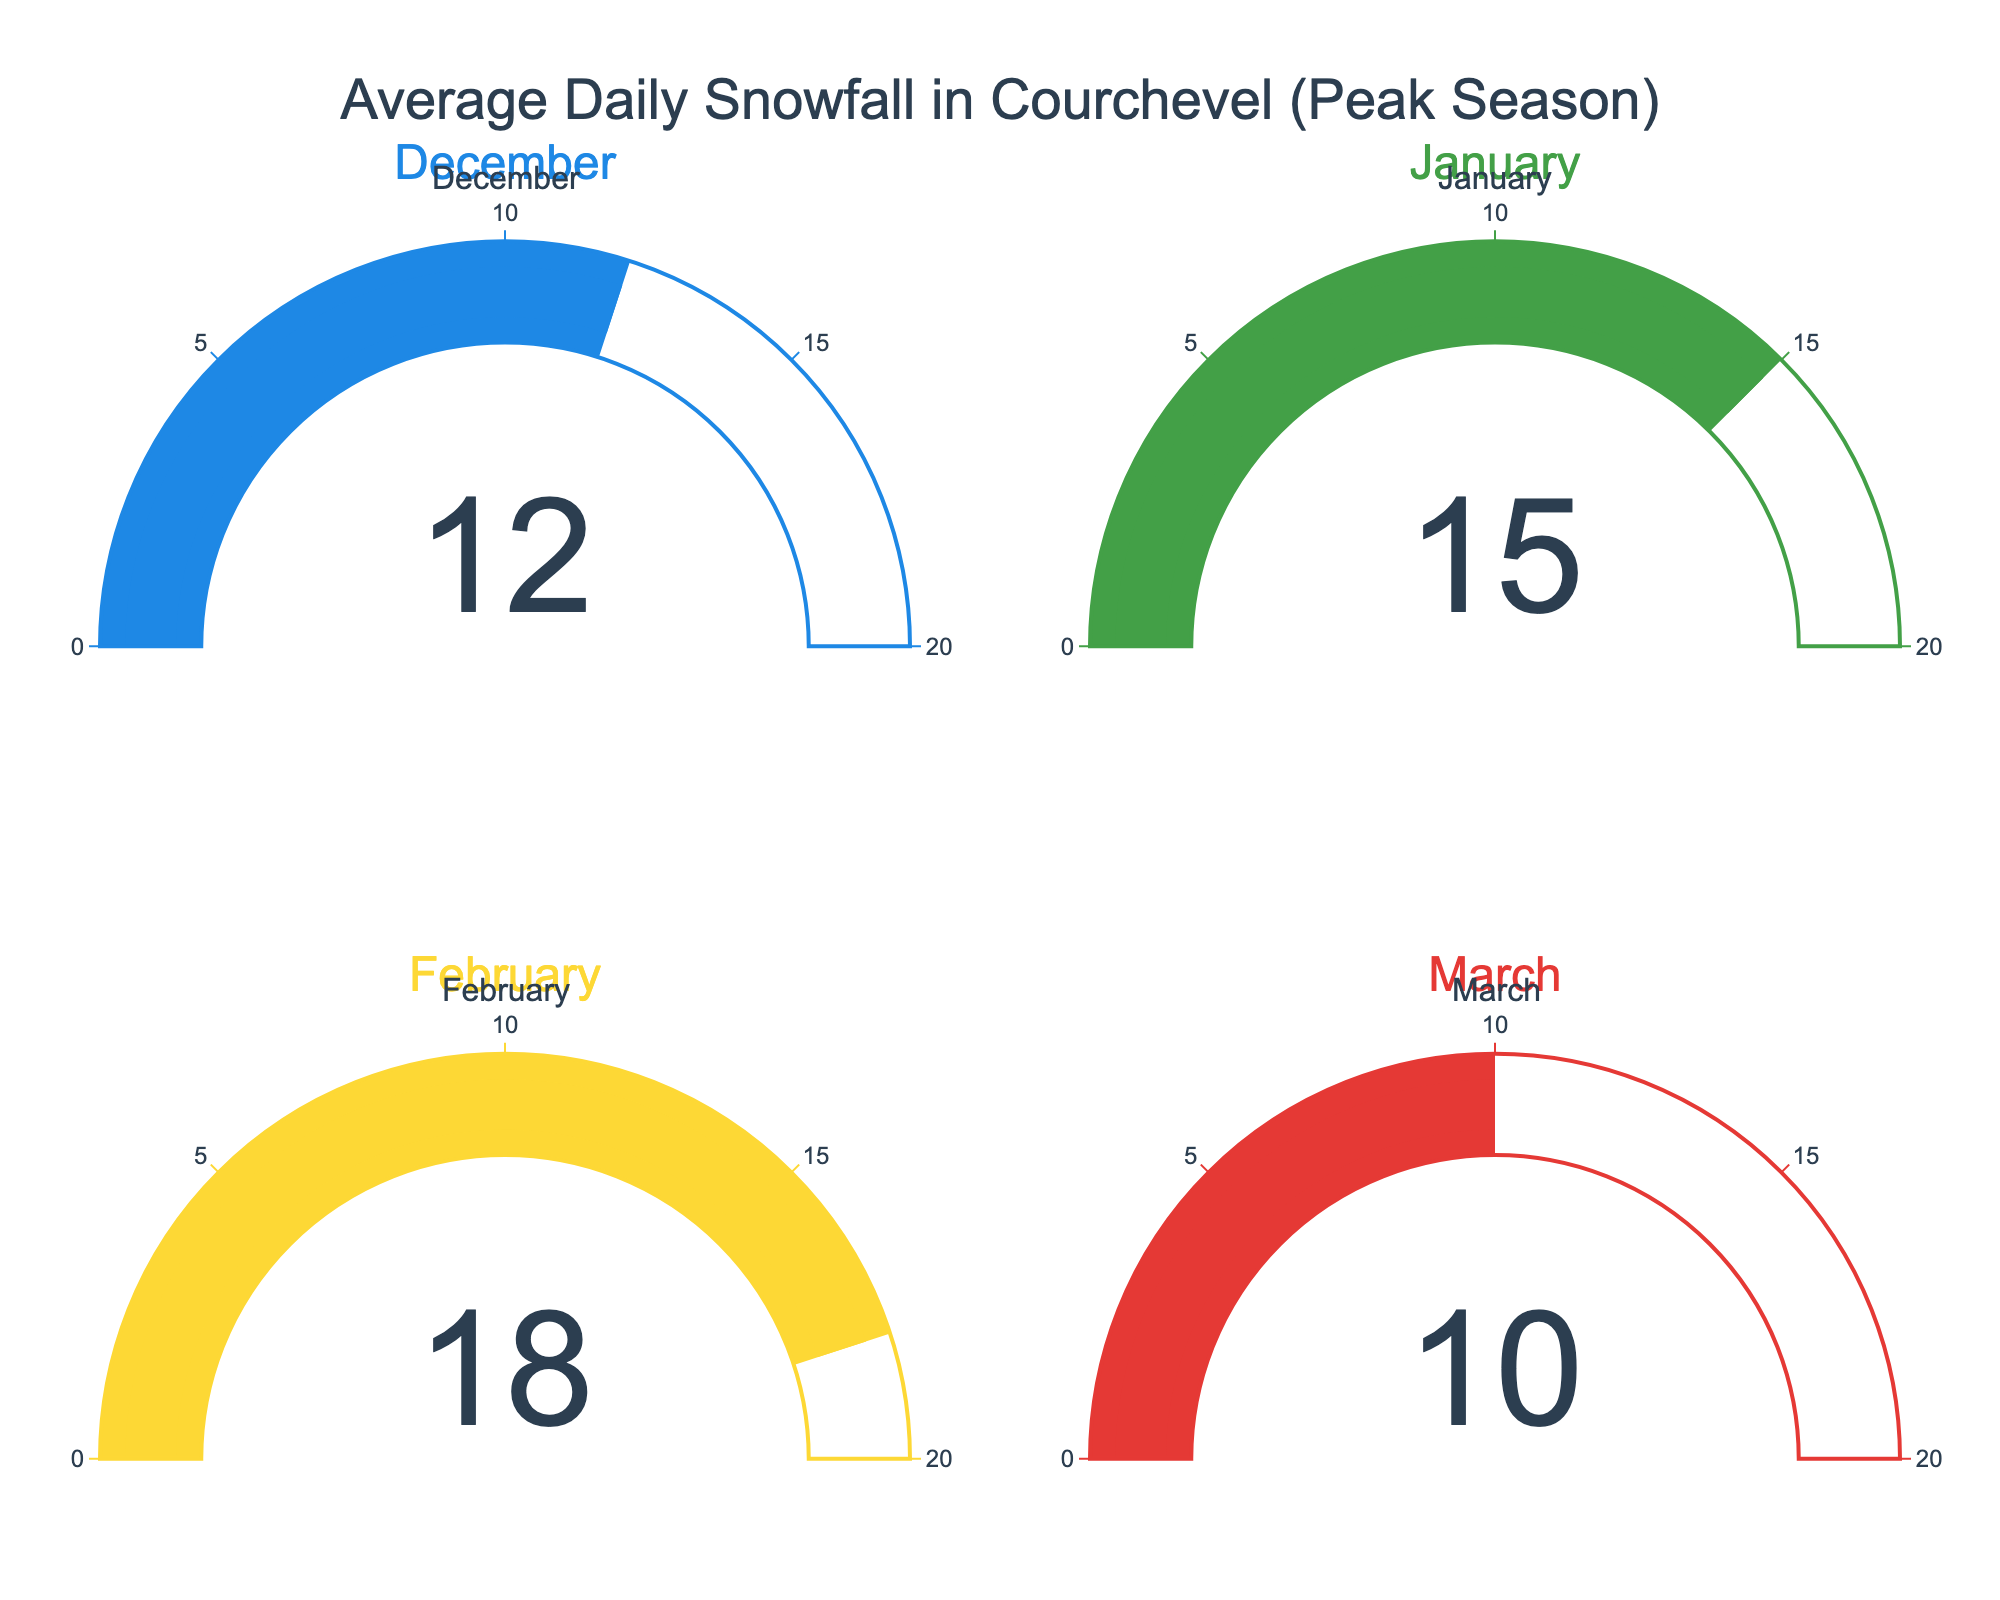What's the title of the figure? The figure's title is given at the top and reads "Average Daily Snowfall in Courchevel (Peak Season)".
Answer: Average Daily Snowfall in Courchevel (Peak Season) What is the average daily snowfall in December? Observing the gauge corresponding to December, the displayed number is 12 cm.
Answer: 12 cm Which month has the highest average daily snowfall? By comparing the values on all the gauges, February shows the highest value of 18 cm.
Answer: February How much lower is the average daily snowfall in March compared to January? The average daily snowfall in March is 10 cm, and in January, it is 15 cm. Subtracting March's value from January's: 15 cm - 10 cm = 5 cm.
Answer: 5 cm What's the combined average daily snowfall of January and February? Adding the values from gauges for January and February: 15 cm + 18 cm = 33 cm.
Answer: 33 cm Which month has the least average daily snowfall? By inspecting the gauges, March has the least snowfall with a value of 10 cm.
Answer: March What is the difference in average daily snowfall between the month with the most snowfall and the month with the least snowfall? The month with the most snowfall is February (18 cm), and the month with the least is March (10 cm). Subtracting these values: 18 cm - 10 cm = 8 cm.
Answer: 8 cm Is the average daily snowfall in January greater than December? January's average daily snowfall is 15 cm, while December's is 12 cm. Since 15 cm is greater than 12 cm, yes, January's is greater.
Answer: Yes What is the median value of average daily snowfall presented in the figure? The sorted values are: 10 cm (March), 12 cm (December), 15 cm (January), 18 cm (February). The median of four values is the average of the two middle values (12 cm and 15 cm): (12 cm + 15 cm) / 2 = 13.5 cm.
Answer: 13.5 cm 